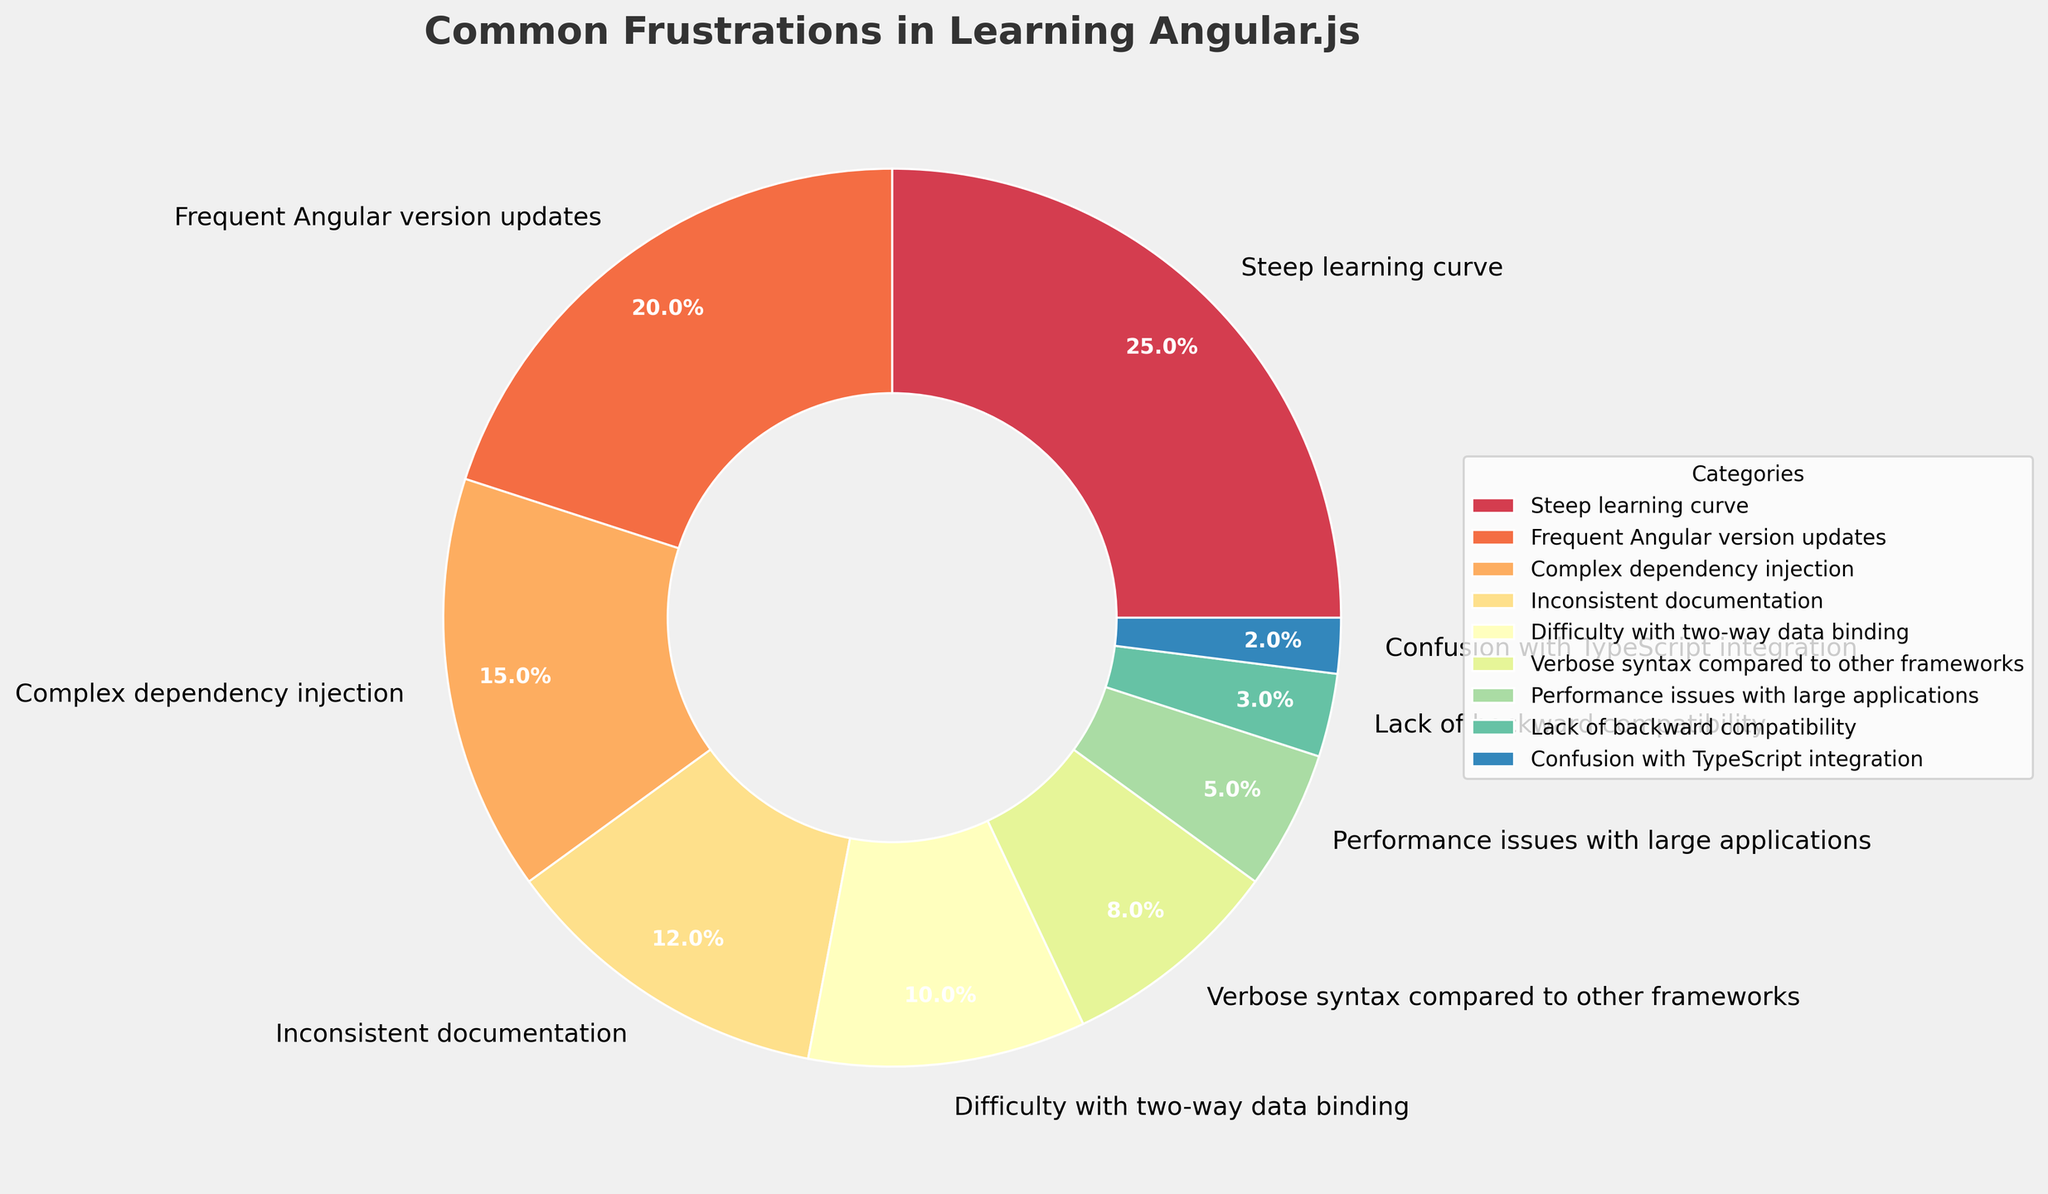Which category has the highest percentage? The category with the largest slice of the pie represents the highest percentage. By visually comparing the sizes of the slices, "Steep learning curve" appears to be the largest.
Answer: Steep learning curve How much larger is the percentage for "Frequent Angular version updates" compared to "Complex dependency injection"? Look at the percentages for both categories. "Frequent Angular version updates" is 20%, and "Complex dependency injection" is 15%. Subtract 15% from 20%.
Answer: 5% What is the combined percentage of "Difficulty with two-way data binding" and "Verbose syntax compared to other frameworks"? Add the percentages of the two categories: 10% for "Difficulty with two-way data binding" and 8% for "Verbose syntax compared to other frameworks".
Answer: 18% Which category has the smallest slice and what is its percentage? The smallest slice visually represents the smallest percentage. "Confusion with TypeScript integration" is the smallest with 2%.
Answer: Confusion with TypeScript integration What percentage of frustrations are related to "Performance issues" and "Lack of backward compatibility" together? Sum the percentages of "Performance issues with large applications" (5%) and "Lack of backward compatibility" (3%).
Answer: 8% Is the percentage of "Inconsistent documentation" higher or lower than "Difficulty with two-way data binding"? Compare the two percentages: "Inconsistent documentation" is 12%, and "Difficulty with two-way data binding" is 10%.
Answer: Higher Rank the top three frustrations by percentage. Order the categories by their percentages: 1) Steep learning curve (25%), 2) Frequent Angular version updates (20%), and 3) Complex dependency injection (15%).
Answer: 1) Steep learning curve, 2) Frequent Angular version updates, 3) Complex dependency injection What is the difference in percentage between "Verbose syntax compared to other frameworks" and "Performance issues with large applications"? Subtract the smaller percentage from the larger one: 8% for "Verbose syntax compared to other frameworks" and 5% for "Performance issues with large applications".
Answer: 3% Which categories have a percentage lower than 5% and what are they collectively referred to? Identify categories with percentages below 5%: "Performance issues with large applications" (5%), "Lack of backward compatibility" (3%), and "Confusion with TypeScript integration" (2%). They can be collectively referred to as minor frustrations.
Answer: Performance issues, Lack of backward compatibility, and Confusion with TypeScript integration What is the average percentage of the frustrations mentioned in the chart? Add all the percentages and divide by the number of categories. (25 + 20 + 15 + 12 + 10 + 8 + 5 + 3 + 2)/9 = 11.1%
Answer: 11.1% 